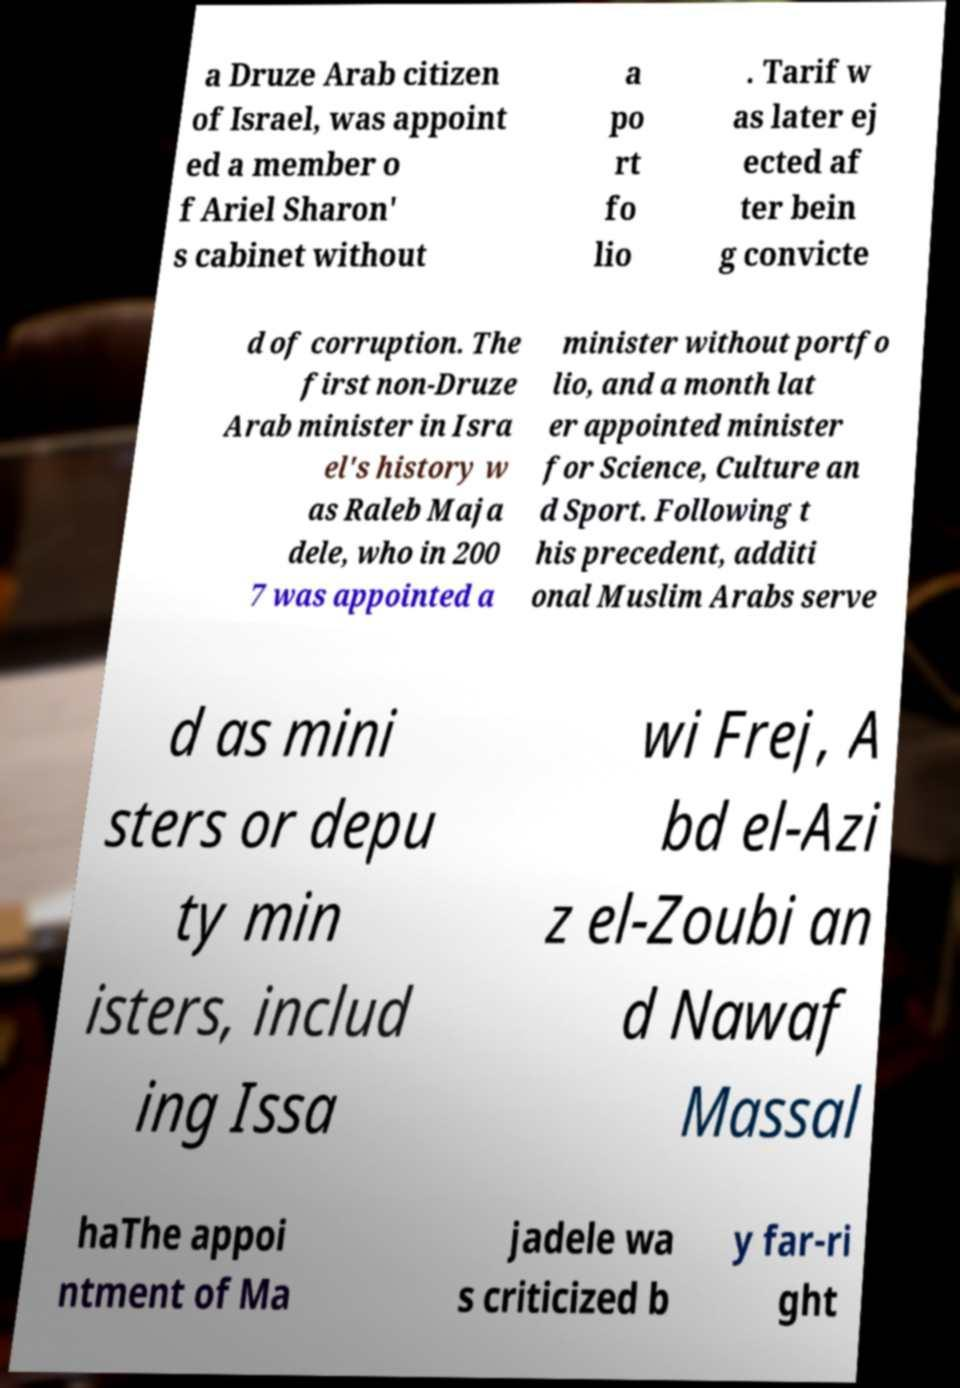Please identify and transcribe the text found in this image. a Druze Arab citizen of Israel, was appoint ed a member o f Ariel Sharon' s cabinet without a po rt fo lio . Tarif w as later ej ected af ter bein g convicte d of corruption. The first non-Druze Arab minister in Isra el's history w as Raleb Maja dele, who in 200 7 was appointed a minister without portfo lio, and a month lat er appointed minister for Science, Culture an d Sport. Following t his precedent, additi onal Muslim Arabs serve d as mini sters or depu ty min isters, includ ing Issa wi Frej, A bd el-Azi z el-Zoubi an d Nawaf Massal haThe appoi ntment of Ma jadele wa s criticized b y far-ri ght 